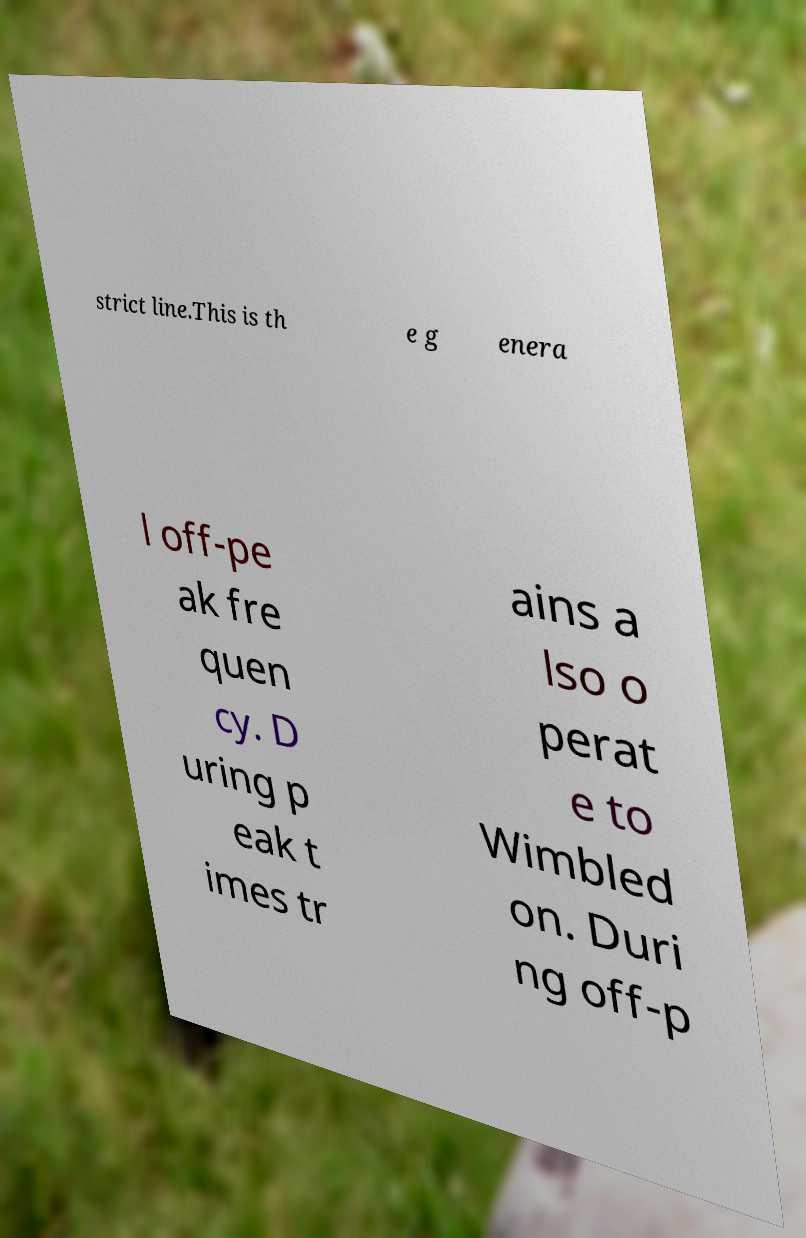Could you extract and type out the text from this image? strict line.This is th e g enera l off-pe ak fre quen cy. D uring p eak t imes tr ains a lso o perat e to Wimbled on. Duri ng off-p 